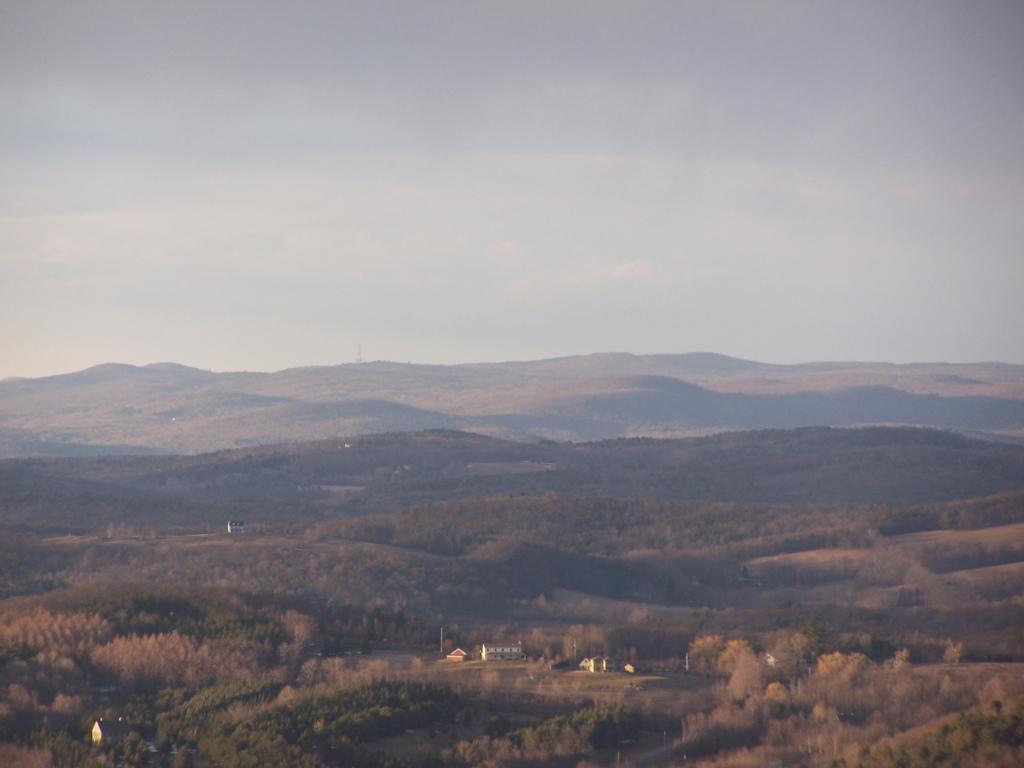Can you describe this image briefly? In this picture we can see some trees here, there is a building where, we can see the sky at the top of the picture. 